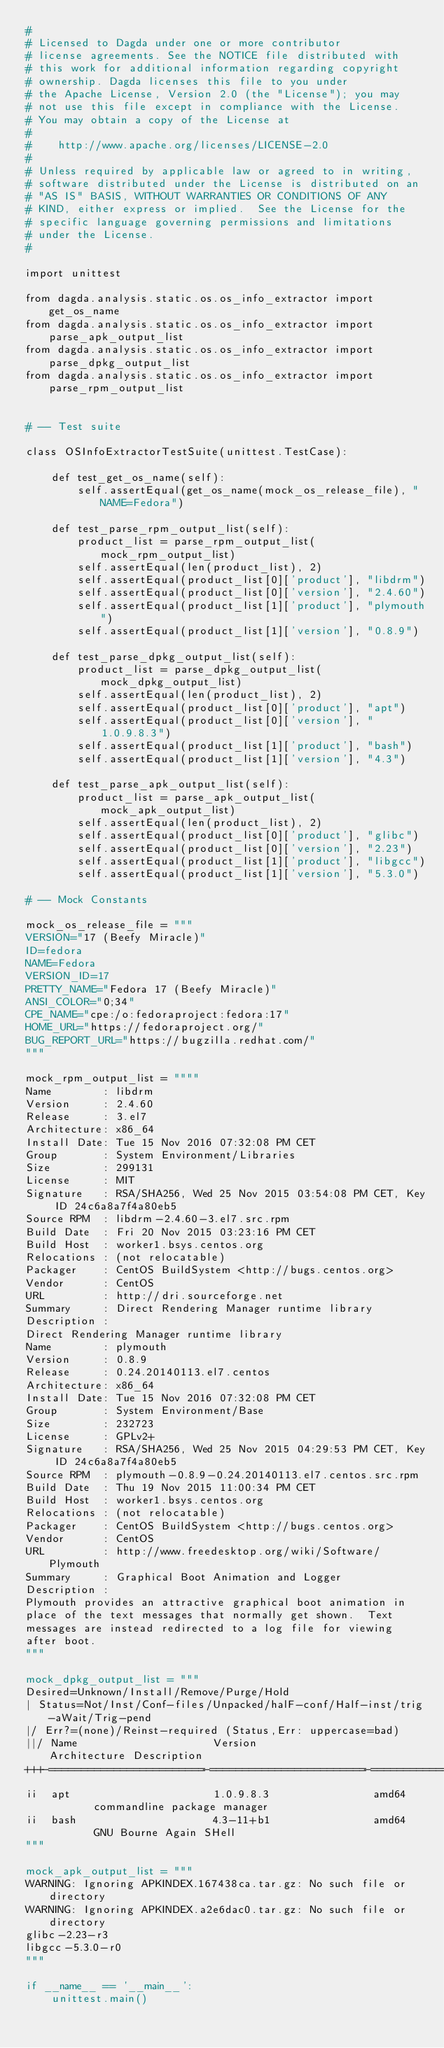<code> <loc_0><loc_0><loc_500><loc_500><_Python_>#
# Licensed to Dagda under one or more contributor
# license agreements. See the NOTICE file distributed with
# this work for additional information regarding copyright
# ownership. Dagda licenses this file to you under
# the Apache License, Version 2.0 (the "License"); you may
# not use this file except in compliance with the License.
# You may obtain a copy of the License at
#
#    http://www.apache.org/licenses/LICENSE-2.0
#
# Unless required by applicable law or agreed to in writing,
# software distributed under the License is distributed on an
# "AS IS" BASIS, WITHOUT WARRANTIES OR CONDITIONS OF ANY
# KIND, either express or implied.  See the License for the
# specific language governing permissions and limitations
# under the License.
#

import unittest

from dagda.analysis.static.os.os_info_extractor import get_os_name
from dagda.analysis.static.os.os_info_extractor import parse_apk_output_list
from dagda.analysis.static.os.os_info_extractor import parse_dpkg_output_list
from dagda.analysis.static.os.os_info_extractor import parse_rpm_output_list


# -- Test suite

class OSInfoExtractorTestSuite(unittest.TestCase):

    def test_get_os_name(self):
        self.assertEqual(get_os_name(mock_os_release_file), "NAME=Fedora")

    def test_parse_rpm_output_list(self):
        product_list = parse_rpm_output_list(mock_rpm_output_list)
        self.assertEqual(len(product_list), 2)
        self.assertEqual(product_list[0]['product'], "libdrm")
        self.assertEqual(product_list[0]['version'], "2.4.60")
        self.assertEqual(product_list[1]['product'], "plymouth")
        self.assertEqual(product_list[1]['version'], "0.8.9")

    def test_parse_dpkg_output_list(self):
        product_list = parse_dpkg_output_list(mock_dpkg_output_list)
        self.assertEqual(len(product_list), 2)
        self.assertEqual(product_list[0]['product'], "apt")
        self.assertEqual(product_list[0]['version'], "1.0.9.8.3")
        self.assertEqual(product_list[1]['product'], "bash")
        self.assertEqual(product_list[1]['version'], "4.3")

    def test_parse_apk_output_list(self):
        product_list = parse_apk_output_list(mock_apk_output_list)
        self.assertEqual(len(product_list), 2)
        self.assertEqual(product_list[0]['product'], "glibc")
        self.assertEqual(product_list[0]['version'], "2.23")
        self.assertEqual(product_list[1]['product'], "libgcc")
        self.assertEqual(product_list[1]['version'], "5.3.0")

# -- Mock Constants

mock_os_release_file = """
VERSION="17 (Beefy Miracle)"
ID=fedora
NAME=Fedora
VERSION_ID=17
PRETTY_NAME="Fedora 17 (Beefy Miracle)"
ANSI_COLOR="0;34"
CPE_NAME="cpe:/o:fedoraproject:fedora:17"
HOME_URL="https://fedoraproject.org/"
BUG_REPORT_URL="https://bugzilla.redhat.com/"
"""

mock_rpm_output_list = """"
Name        : libdrm
Version     : 2.4.60
Release     : 3.el7
Architecture: x86_64
Install Date: Tue 15 Nov 2016 07:32:08 PM CET
Group       : System Environment/Libraries
Size        : 299131
License     : MIT
Signature   : RSA/SHA256, Wed 25 Nov 2015 03:54:08 PM CET, Key ID 24c6a8a7f4a80eb5
Source RPM  : libdrm-2.4.60-3.el7.src.rpm
Build Date  : Fri 20 Nov 2015 03:23:16 PM CET
Build Host  : worker1.bsys.centos.org
Relocations : (not relocatable)
Packager    : CentOS BuildSystem <http://bugs.centos.org>
Vendor      : CentOS
URL         : http://dri.sourceforge.net
Summary     : Direct Rendering Manager runtime library
Description :
Direct Rendering Manager runtime library
Name        : plymouth
Version     : 0.8.9
Release     : 0.24.20140113.el7.centos
Architecture: x86_64
Install Date: Tue 15 Nov 2016 07:32:08 PM CET
Group       : System Environment/Base
Size        : 232723
License     : GPLv2+
Signature   : RSA/SHA256, Wed 25 Nov 2015 04:29:53 PM CET, Key ID 24c6a8a7f4a80eb5
Source RPM  : plymouth-0.8.9-0.24.20140113.el7.centos.src.rpm
Build Date  : Thu 19 Nov 2015 11:00:34 PM CET
Build Host  : worker1.bsys.centos.org
Relocations : (not relocatable)
Packager    : CentOS BuildSystem <http://bugs.centos.org>
Vendor      : CentOS
URL         : http://www.freedesktop.org/wiki/Software/Plymouth
Summary     : Graphical Boot Animation and Logger
Description :
Plymouth provides an attractive graphical boot animation in
place of the text messages that normally get shown.  Text
messages are instead redirected to a log file for viewing
after boot.
"""

mock_dpkg_output_list = """
Desired=Unknown/Install/Remove/Purge/Hold
| Status=Not/Inst/Conf-files/Unpacked/halF-conf/Half-inst/trig-aWait/Trig-pend
|/ Err?=(none)/Reinst-required (Status,Err: uppercase=bad)
||/ Name                     Version                  Architecture Description
+++-========================-========================-============-========================================================================
ii  apt                      1.0.9.8.3                amd64        commandline package manager
ii  bash                     4.3-11+b1                amd64        GNU Bourne Again SHell
"""

mock_apk_output_list = """
WARNING: Ignoring APKINDEX.167438ca.tar.gz: No such file or directory
WARNING: Ignoring APKINDEX.a2e6dac0.tar.gz: No such file or directory
glibc-2.23-r3
libgcc-5.3.0-r0
"""

if __name__ == '__main__':
    unittest.main()
</code> 